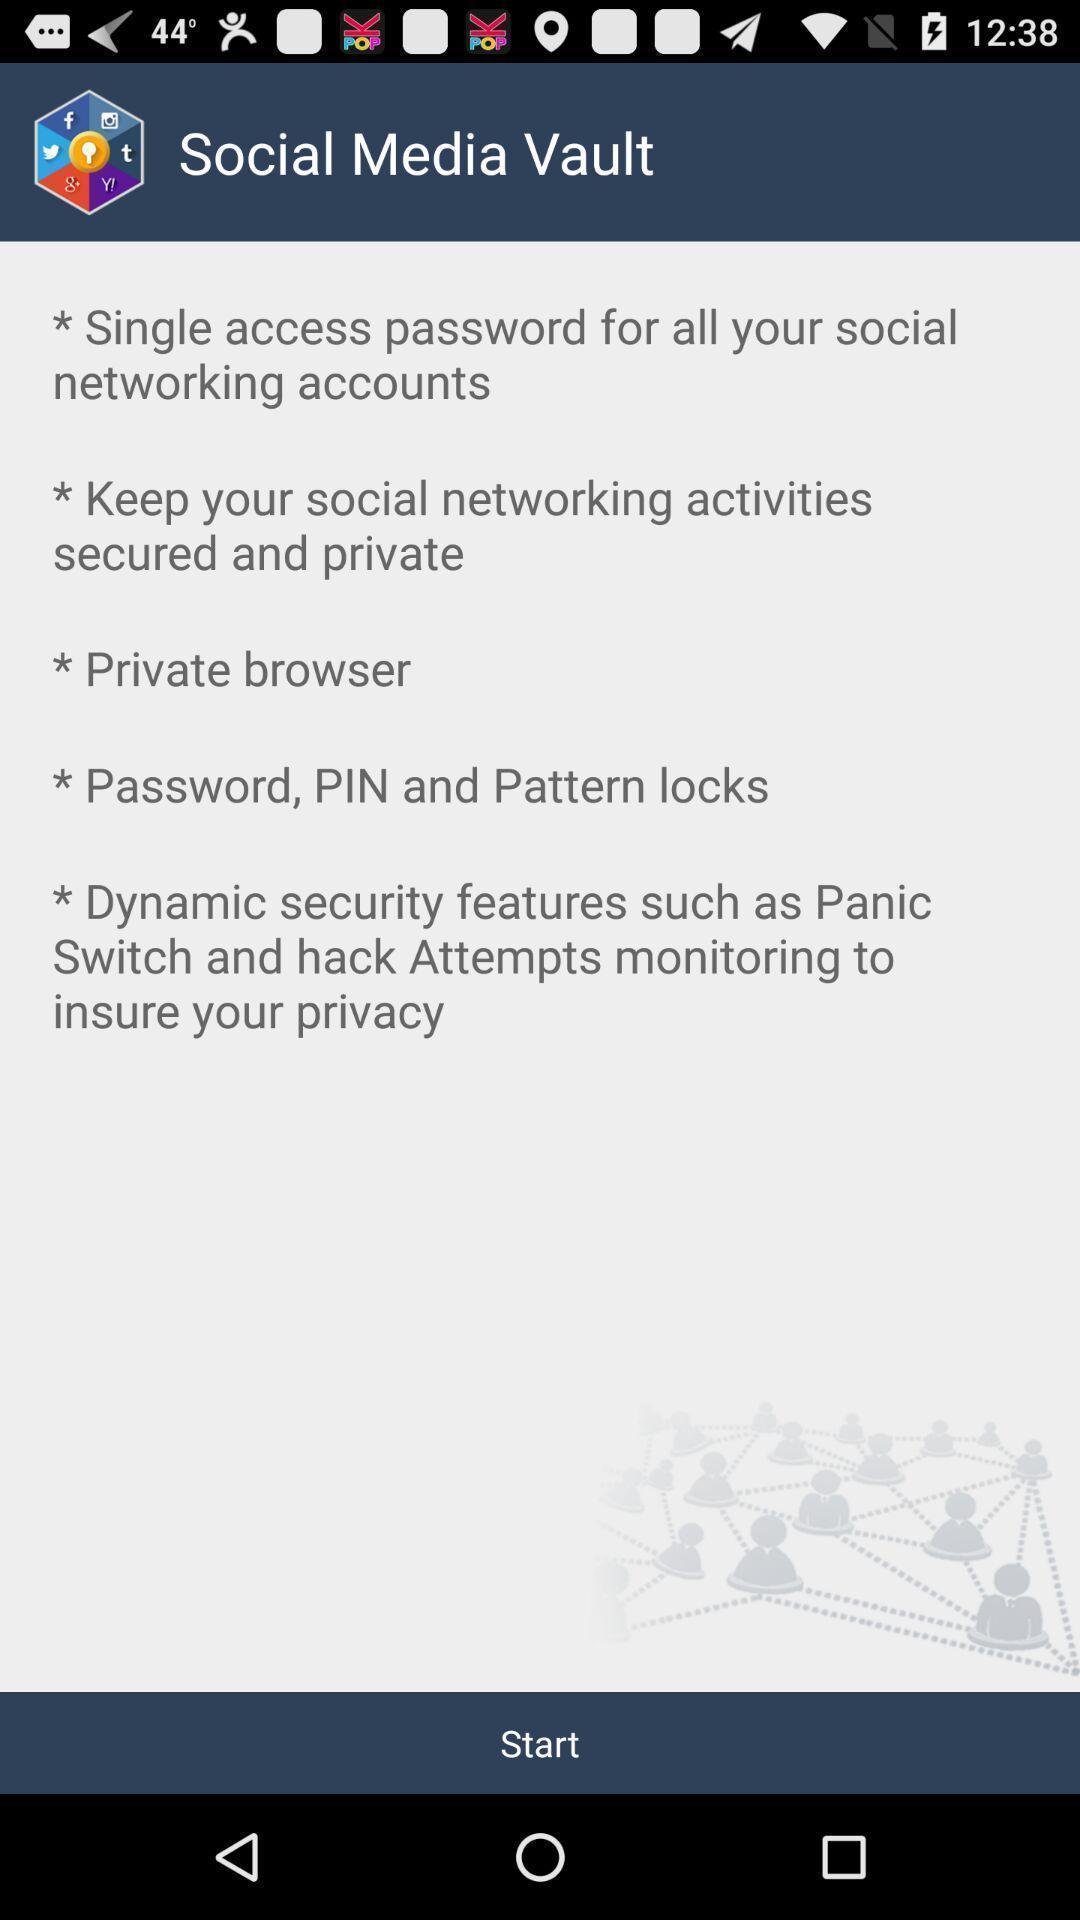Provide a detailed account of this screenshot. Welcome page of social media setting options. 